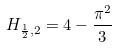Convert formula to latex. <formula><loc_0><loc_0><loc_500><loc_500>H _ { \frac { 1 } { 2 } , 2 } = 4 - \frac { \pi ^ { 2 } } { 3 }</formula> 